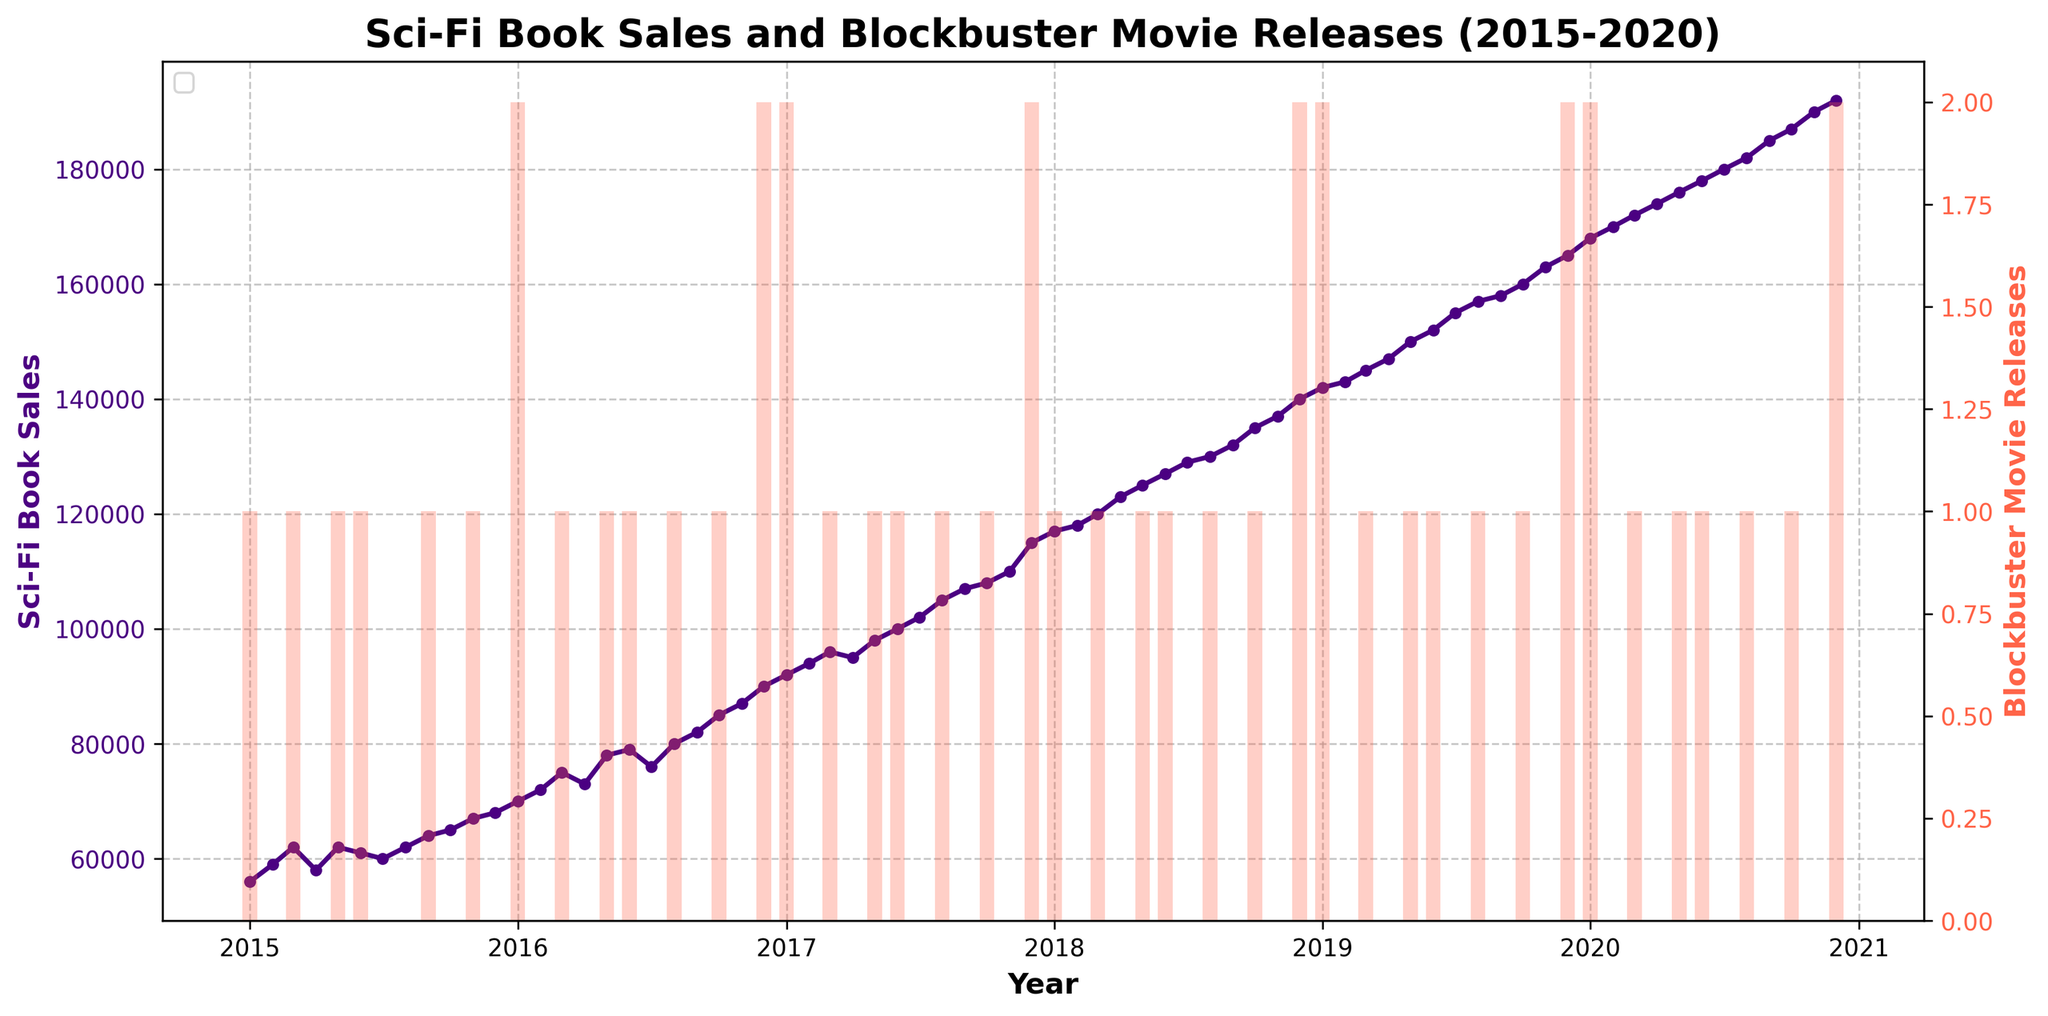What is the title of the plot? The title is usually displayed at the top of the plot, which provides an overview of what the plot represents. In this case, the title of the plot is "Sci-Fi Book Sales and Blockbuster Movie Releases (2015-2020)"
Answer: Sci-Fi Book Sales and Blockbuster Movie Releases (2015-2020) What two visual elements are used to represent data in this plot? By analyzing the plot, you can see that there are two types of visual elements: a line plot with markers and a bar plot. The line plot with markers represents Sci-Fi Book Sales, and the bars represent Blockbuster Movie Releases.
Answer: Line plot with markers and bar plot During which year did Sci-Fi book sales first exceed 100,000? To answer this, look for the point on the line plot where the Sci-Fi Book Sales first surpass the 100,000 mark. By inspecting the graph, this happens in the year 2017.
Answer: 2017 How many blockbuster movie releases were there in December 2020? This information can be found by looking at the bars in the plot for December 2020. The height and count of the bar will tell you there were 2 blockbuster movie releases.
Answer: 2 Did Sci-Fi book sales consistently increase every year from 2015 to 2020? By examining the line plot, you can observe the trend in book sales from 2015 through 2020. Although the overall trend is an increase, it is clear there are occasional drops or stagnations, such as in July 2016 and July 2019.
Answer: No What was the Sci-Fi book sales value in January 2018? Find the point on the line plot corresponding to January 2018 and read the sales value. The plot shows that the Sci-Fi book sales in January 2018 were 117,000.
Answer: 117,000 What is the relationship between blockbusters movie releases and Sci-Fi book sales in 2016? To answer this, look at the bar plot (movie releases) and line plot (book sales) data points for 2016. Noticeably, there are several peaks in sales that align with months of blockbuster releases, such as May, June, October, and December 2016. This indicates a potential positive relationship.
Answer: Positive relationship What can you infer about the month with the highest Sci-Fi book sales from 2015 to 2020? Examine the highest point on the Sci-Fi book sales line plot over the entire period. The peak sales value is in December 2020, indicating that the month with the highest sales is December 2020 with 192,000 sales.
Answer: December 2020 Were there any months with zero blockbuster movie releases? Look for months where the bar height is zero. There are several instances in the plot where this occurs, including February 2015 and February 2016.
Answer: Yes 